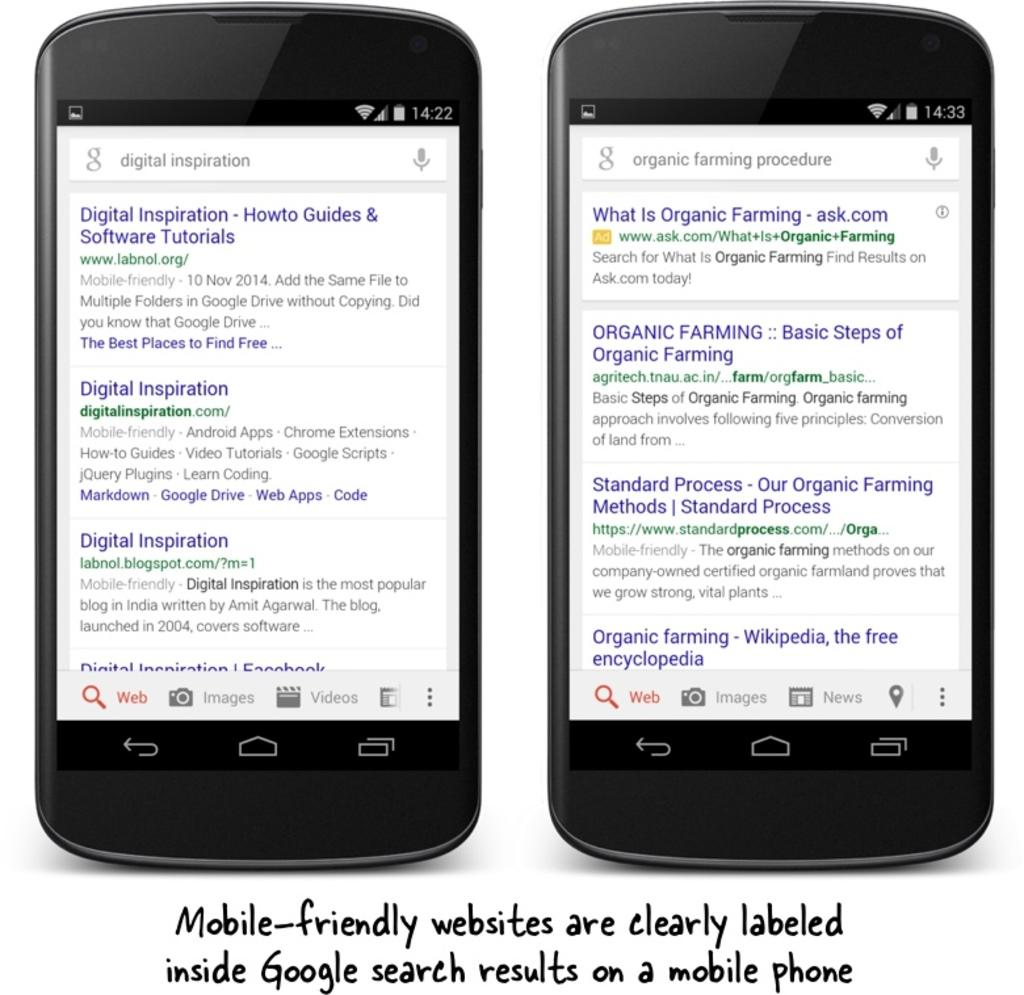Provide a one-sentence caption for the provided image. Google search results are mobile friendly on two black smartphones. 